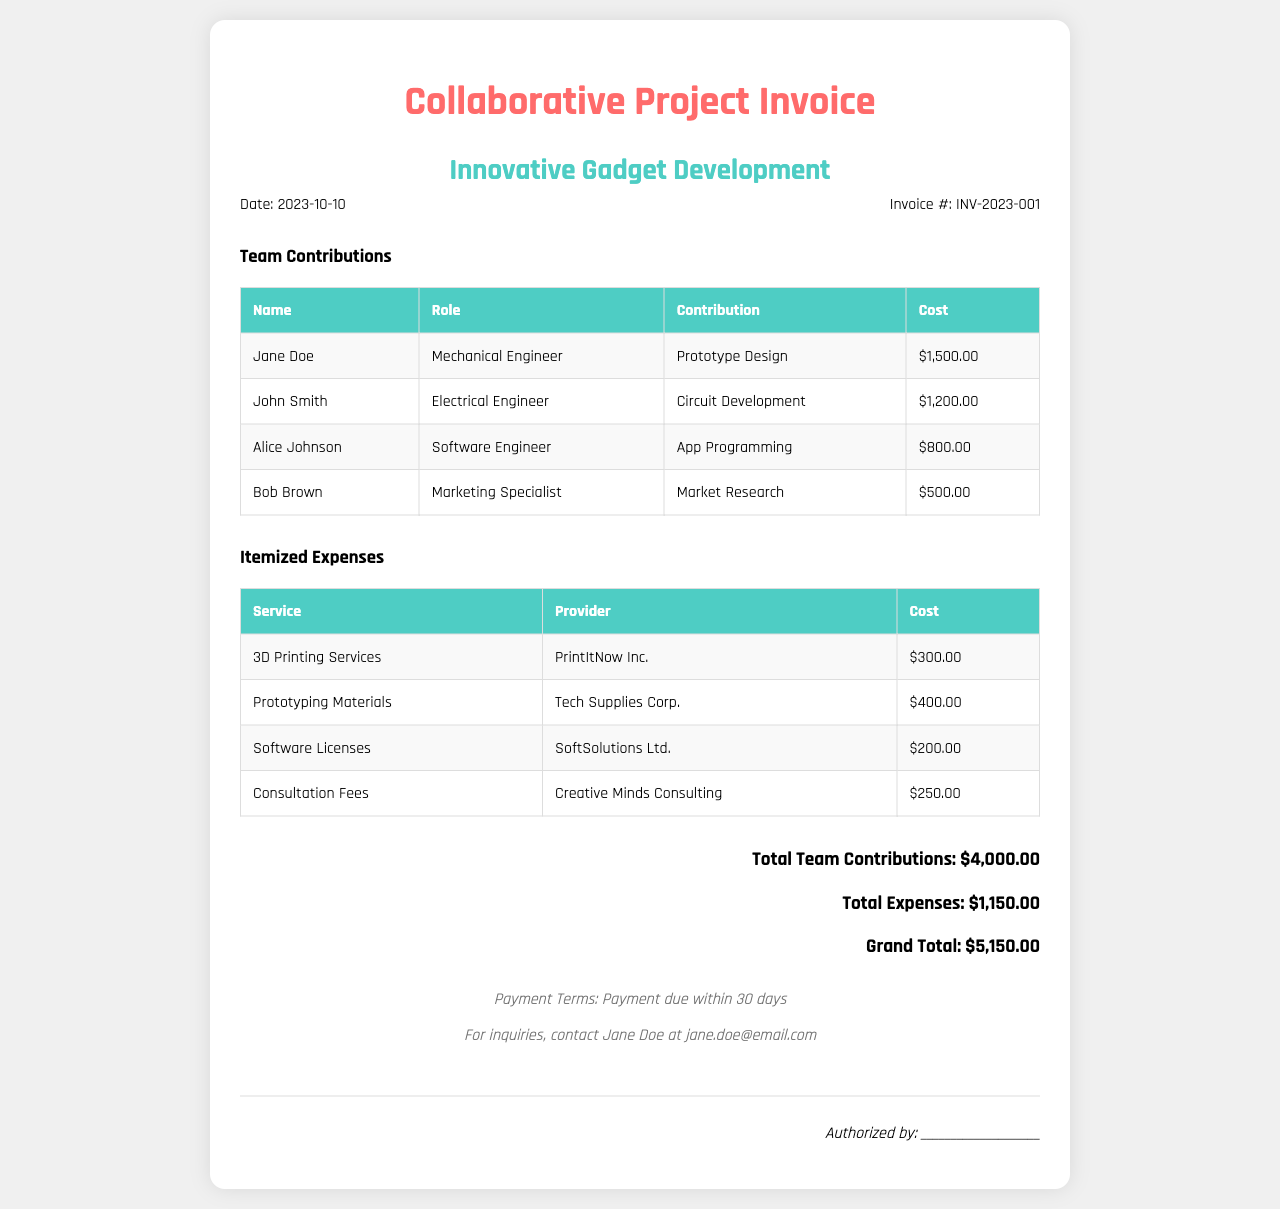What is the date of the invoice? The date of the invoice is stated in the invoice details section.
Answer: 2023-10-10 Who contributed to the Prototype Design? Jane Doe is listed in the Team Contributions section, and her contribution is Prototype Design.
Answer: Jane Doe What is the total amount of team contributions? The total is identified in the total section summarizing all contributions made by team members.
Answer: $4,000.00 How much did the 3D printing services cost? The cost of 3D printing services is specified in the Itemized Expenses section.
Answer: $300.00 Who is responsible for market research? Bob Brown is indicated as the Marketing Specialist contributing to Market Research.
Answer: Bob Brown What is the grand total for the project? The grand total represents the sum of total team contributions and total expenses, shown in the total section.
Answer: $5,150.00 What is the payment term for the invoice? Payment terms are outlined in the footer of the invoice document.
Answer: Payment due within 30 days Which company provided the consultation services? The provider of consultation services is identified in the Itemized Expenses table.
Answer: Creative Minds Consulting 